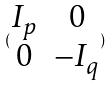<formula> <loc_0><loc_0><loc_500><loc_500>( \begin{matrix} I _ { p } & 0 \\ 0 & - I _ { q } \end{matrix} )</formula> 